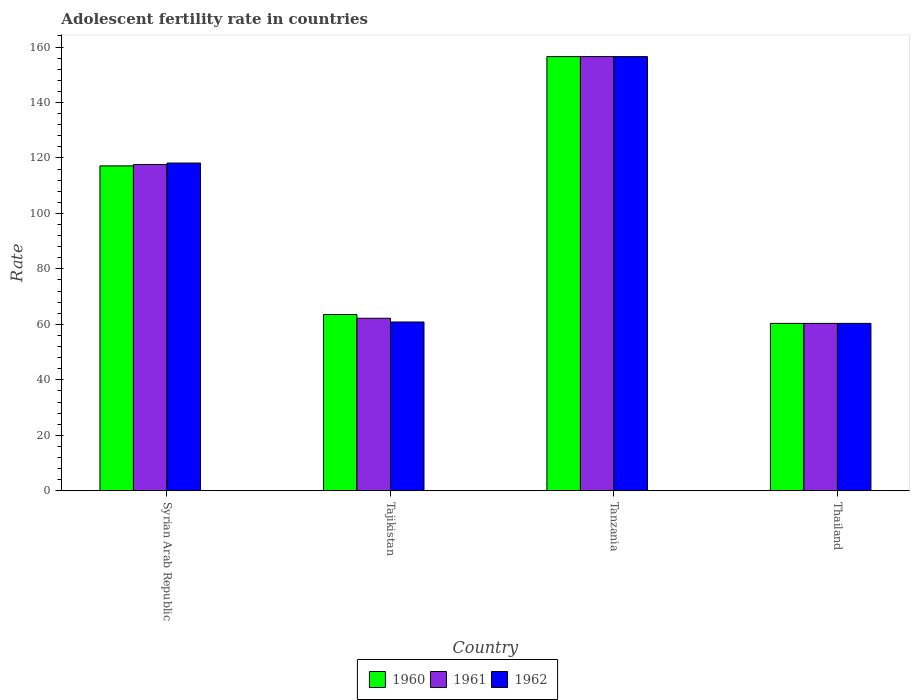How many groups of bars are there?
Your answer should be very brief. 4. What is the label of the 3rd group of bars from the left?
Your answer should be compact. Tanzania. What is the adolescent fertility rate in 1960 in Tanzania?
Offer a terse response. 156.55. Across all countries, what is the maximum adolescent fertility rate in 1962?
Your answer should be very brief. 156.54. Across all countries, what is the minimum adolescent fertility rate in 1960?
Provide a succinct answer. 60.35. In which country was the adolescent fertility rate in 1960 maximum?
Ensure brevity in your answer.  Tanzania. In which country was the adolescent fertility rate in 1961 minimum?
Your response must be concise. Thailand. What is the total adolescent fertility rate in 1961 in the graph?
Keep it short and to the point. 396.74. What is the difference between the adolescent fertility rate in 1961 in Tajikistan and that in Tanzania?
Make the answer very short. -94.34. What is the difference between the adolescent fertility rate in 1961 in Syrian Arab Republic and the adolescent fertility rate in 1962 in Tajikistan?
Your response must be concise. 56.8. What is the average adolescent fertility rate in 1961 per country?
Your response must be concise. 99.19. What is the difference between the adolescent fertility rate of/in 1961 and adolescent fertility rate of/in 1962 in Tanzania?
Your answer should be very brief. 0. In how many countries, is the adolescent fertility rate in 1961 greater than 88?
Offer a very short reply. 2. What is the ratio of the adolescent fertility rate in 1962 in Tajikistan to that in Tanzania?
Your response must be concise. 0.39. Is the adolescent fertility rate in 1960 in Tajikistan less than that in Thailand?
Your answer should be compact. No. What is the difference between the highest and the second highest adolescent fertility rate in 1960?
Provide a succinct answer. 39.41. What is the difference between the highest and the lowest adolescent fertility rate in 1961?
Offer a very short reply. 96.19. What does the 1st bar from the left in Tajikistan represents?
Ensure brevity in your answer.  1960. Is it the case that in every country, the sum of the adolescent fertility rate in 1961 and adolescent fertility rate in 1962 is greater than the adolescent fertility rate in 1960?
Offer a very short reply. Yes. How many bars are there?
Provide a short and direct response. 12. How many countries are there in the graph?
Provide a succinct answer. 4. What is the difference between two consecutive major ticks on the Y-axis?
Give a very brief answer. 20. Are the values on the major ticks of Y-axis written in scientific E-notation?
Offer a terse response. No. Does the graph contain grids?
Ensure brevity in your answer.  No. What is the title of the graph?
Give a very brief answer. Adolescent fertility rate in countries. Does "1998" appear as one of the legend labels in the graph?
Keep it short and to the point. No. What is the label or title of the Y-axis?
Give a very brief answer. Rate. What is the Rate of 1960 in Syrian Arab Republic?
Provide a succinct answer. 117.14. What is the Rate in 1961 in Syrian Arab Republic?
Provide a succinct answer. 117.65. What is the Rate of 1962 in Syrian Arab Republic?
Offer a terse response. 118.16. What is the Rate in 1960 in Tajikistan?
Your answer should be compact. 63.55. What is the Rate of 1961 in Tajikistan?
Give a very brief answer. 62.2. What is the Rate of 1962 in Tajikistan?
Give a very brief answer. 60.85. What is the Rate in 1960 in Tanzania?
Your answer should be compact. 156.55. What is the Rate of 1961 in Tanzania?
Provide a short and direct response. 156.54. What is the Rate in 1962 in Tanzania?
Make the answer very short. 156.54. What is the Rate in 1960 in Thailand?
Give a very brief answer. 60.35. What is the Rate in 1961 in Thailand?
Your answer should be very brief. 60.35. What is the Rate in 1962 in Thailand?
Provide a succinct answer. 60.35. Across all countries, what is the maximum Rate of 1960?
Offer a terse response. 156.55. Across all countries, what is the maximum Rate in 1961?
Your answer should be compact. 156.54. Across all countries, what is the maximum Rate of 1962?
Your response must be concise. 156.54. Across all countries, what is the minimum Rate of 1960?
Your response must be concise. 60.35. Across all countries, what is the minimum Rate of 1961?
Your response must be concise. 60.35. Across all countries, what is the minimum Rate of 1962?
Provide a short and direct response. 60.35. What is the total Rate in 1960 in the graph?
Provide a short and direct response. 397.58. What is the total Rate of 1961 in the graph?
Keep it short and to the point. 396.74. What is the total Rate of 1962 in the graph?
Your answer should be very brief. 395.9. What is the difference between the Rate in 1960 in Syrian Arab Republic and that in Tajikistan?
Your answer should be compact. 53.59. What is the difference between the Rate of 1961 in Syrian Arab Republic and that in Tajikistan?
Your answer should be compact. 55.45. What is the difference between the Rate of 1962 in Syrian Arab Republic and that in Tajikistan?
Keep it short and to the point. 57.31. What is the difference between the Rate in 1960 in Syrian Arab Republic and that in Tanzania?
Your response must be concise. -39.41. What is the difference between the Rate of 1961 in Syrian Arab Republic and that in Tanzania?
Make the answer very short. -38.89. What is the difference between the Rate of 1962 in Syrian Arab Republic and that in Tanzania?
Make the answer very short. -38.38. What is the difference between the Rate of 1960 in Syrian Arab Republic and that in Thailand?
Provide a short and direct response. 56.79. What is the difference between the Rate in 1961 in Syrian Arab Republic and that in Thailand?
Ensure brevity in your answer.  57.3. What is the difference between the Rate in 1962 in Syrian Arab Republic and that in Thailand?
Make the answer very short. 57.81. What is the difference between the Rate in 1960 in Tajikistan and that in Tanzania?
Make the answer very short. -93. What is the difference between the Rate in 1961 in Tajikistan and that in Tanzania?
Offer a terse response. -94.34. What is the difference between the Rate in 1962 in Tajikistan and that in Tanzania?
Make the answer very short. -95.68. What is the difference between the Rate in 1960 in Tajikistan and that in Thailand?
Make the answer very short. 3.2. What is the difference between the Rate of 1961 in Tajikistan and that in Thailand?
Your answer should be very brief. 1.85. What is the difference between the Rate in 1962 in Tajikistan and that in Thailand?
Make the answer very short. 0.5. What is the difference between the Rate in 1960 in Tanzania and that in Thailand?
Ensure brevity in your answer.  96.19. What is the difference between the Rate in 1961 in Tanzania and that in Thailand?
Your answer should be compact. 96.19. What is the difference between the Rate of 1962 in Tanzania and that in Thailand?
Your response must be concise. 96.18. What is the difference between the Rate of 1960 in Syrian Arab Republic and the Rate of 1961 in Tajikistan?
Ensure brevity in your answer.  54.94. What is the difference between the Rate in 1960 in Syrian Arab Republic and the Rate in 1962 in Tajikistan?
Your answer should be compact. 56.29. What is the difference between the Rate of 1961 in Syrian Arab Republic and the Rate of 1962 in Tajikistan?
Provide a succinct answer. 56.8. What is the difference between the Rate of 1960 in Syrian Arab Republic and the Rate of 1961 in Tanzania?
Offer a terse response. -39.4. What is the difference between the Rate of 1960 in Syrian Arab Republic and the Rate of 1962 in Tanzania?
Ensure brevity in your answer.  -39.4. What is the difference between the Rate in 1961 in Syrian Arab Republic and the Rate in 1962 in Tanzania?
Provide a short and direct response. -38.89. What is the difference between the Rate in 1960 in Syrian Arab Republic and the Rate in 1961 in Thailand?
Offer a terse response. 56.79. What is the difference between the Rate in 1960 in Syrian Arab Republic and the Rate in 1962 in Thailand?
Offer a terse response. 56.78. What is the difference between the Rate of 1961 in Syrian Arab Republic and the Rate of 1962 in Thailand?
Give a very brief answer. 57.3. What is the difference between the Rate of 1960 in Tajikistan and the Rate of 1961 in Tanzania?
Provide a succinct answer. -92.99. What is the difference between the Rate in 1960 in Tajikistan and the Rate in 1962 in Tanzania?
Your answer should be very brief. -92.99. What is the difference between the Rate in 1961 in Tajikistan and the Rate in 1962 in Tanzania?
Give a very brief answer. -94.34. What is the difference between the Rate in 1960 in Tajikistan and the Rate in 1961 in Thailand?
Keep it short and to the point. 3.2. What is the difference between the Rate of 1960 in Tajikistan and the Rate of 1962 in Thailand?
Ensure brevity in your answer.  3.2. What is the difference between the Rate in 1961 in Tajikistan and the Rate in 1962 in Thailand?
Keep it short and to the point. 1.85. What is the difference between the Rate of 1960 in Tanzania and the Rate of 1961 in Thailand?
Make the answer very short. 96.19. What is the difference between the Rate of 1960 in Tanzania and the Rate of 1962 in Thailand?
Keep it short and to the point. 96.19. What is the difference between the Rate of 1961 in Tanzania and the Rate of 1962 in Thailand?
Make the answer very short. 96.19. What is the average Rate of 1960 per country?
Provide a succinct answer. 99.4. What is the average Rate in 1961 per country?
Provide a short and direct response. 99.19. What is the average Rate in 1962 per country?
Offer a very short reply. 98.98. What is the difference between the Rate of 1960 and Rate of 1961 in Syrian Arab Republic?
Keep it short and to the point. -0.51. What is the difference between the Rate in 1960 and Rate in 1962 in Syrian Arab Republic?
Offer a terse response. -1.02. What is the difference between the Rate of 1961 and Rate of 1962 in Syrian Arab Republic?
Offer a very short reply. -0.51. What is the difference between the Rate in 1960 and Rate in 1961 in Tajikistan?
Your answer should be compact. 1.35. What is the difference between the Rate in 1960 and Rate in 1962 in Tajikistan?
Your response must be concise. 2.7. What is the difference between the Rate in 1961 and Rate in 1962 in Tajikistan?
Give a very brief answer. 1.35. What is the difference between the Rate in 1960 and Rate in 1961 in Tanzania?
Your answer should be compact. 0. What is the difference between the Rate of 1960 and Rate of 1962 in Tanzania?
Offer a terse response. 0.01. What is the difference between the Rate in 1961 and Rate in 1962 in Tanzania?
Provide a short and direct response. 0. What is the difference between the Rate in 1960 and Rate in 1961 in Thailand?
Provide a succinct answer. -0. What is the difference between the Rate of 1960 and Rate of 1962 in Thailand?
Give a very brief answer. -0. What is the difference between the Rate of 1961 and Rate of 1962 in Thailand?
Offer a terse response. -0. What is the ratio of the Rate in 1960 in Syrian Arab Republic to that in Tajikistan?
Offer a terse response. 1.84. What is the ratio of the Rate in 1961 in Syrian Arab Republic to that in Tajikistan?
Make the answer very short. 1.89. What is the ratio of the Rate of 1962 in Syrian Arab Republic to that in Tajikistan?
Your answer should be compact. 1.94. What is the ratio of the Rate in 1960 in Syrian Arab Republic to that in Tanzania?
Give a very brief answer. 0.75. What is the ratio of the Rate of 1961 in Syrian Arab Republic to that in Tanzania?
Your answer should be very brief. 0.75. What is the ratio of the Rate in 1962 in Syrian Arab Republic to that in Tanzania?
Make the answer very short. 0.75. What is the ratio of the Rate in 1960 in Syrian Arab Republic to that in Thailand?
Provide a short and direct response. 1.94. What is the ratio of the Rate in 1961 in Syrian Arab Republic to that in Thailand?
Your response must be concise. 1.95. What is the ratio of the Rate in 1962 in Syrian Arab Republic to that in Thailand?
Your response must be concise. 1.96. What is the ratio of the Rate of 1960 in Tajikistan to that in Tanzania?
Your response must be concise. 0.41. What is the ratio of the Rate of 1961 in Tajikistan to that in Tanzania?
Give a very brief answer. 0.4. What is the ratio of the Rate of 1962 in Tajikistan to that in Tanzania?
Your answer should be very brief. 0.39. What is the ratio of the Rate in 1960 in Tajikistan to that in Thailand?
Give a very brief answer. 1.05. What is the ratio of the Rate of 1961 in Tajikistan to that in Thailand?
Give a very brief answer. 1.03. What is the ratio of the Rate of 1962 in Tajikistan to that in Thailand?
Your answer should be compact. 1.01. What is the ratio of the Rate in 1960 in Tanzania to that in Thailand?
Ensure brevity in your answer.  2.59. What is the ratio of the Rate in 1961 in Tanzania to that in Thailand?
Your response must be concise. 2.59. What is the ratio of the Rate in 1962 in Tanzania to that in Thailand?
Provide a short and direct response. 2.59. What is the difference between the highest and the second highest Rate in 1960?
Offer a terse response. 39.41. What is the difference between the highest and the second highest Rate of 1961?
Ensure brevity in your answer.  38.89. What is the difference between the highest and the second highest Rate in 1962?
Ensure brevity in your answer.  38.38. What is the difference between the highest and the lowest Rate in 1960?
Provide a succinct answer. 96.19. What is the difference between the highest and the lowest Rate of 1961?
Provide a short and direct response. 96.19. What is the difference between the highest and the lowest Rate of 1962?
Keep it short and to the point. 96.18. 